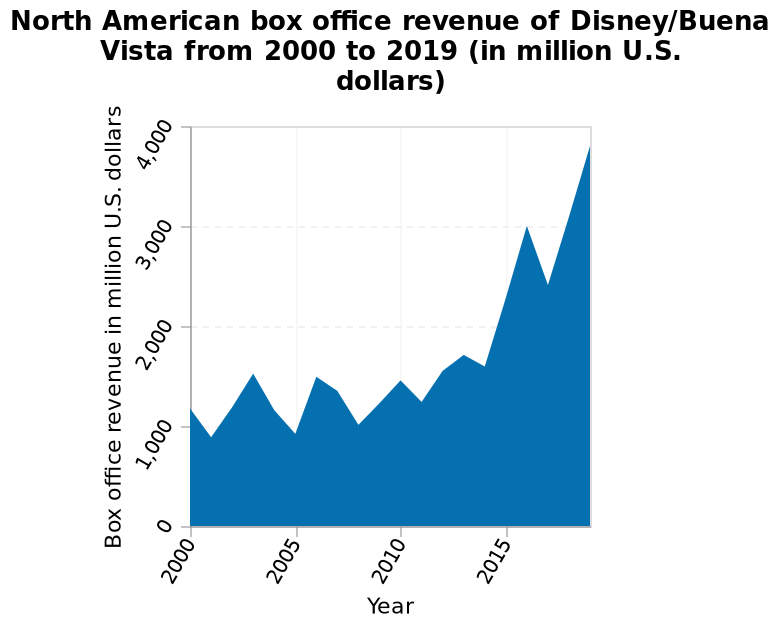<image>
please describe the details of the chart Here a is a area diagram titled North American box office revenue of Disney/Buena Vista from 2000 to 2019 (in million U.S. dollars). The y-axis shows Box office revenue in million U.S. dollars with linear scale from 0 to 4,000 while the x-axis measures Year using linear scale of range 2000 to 2015. please summary the statistics and relations of the chart Despite some drops in revenue, the chart shows a steady increase. 2019 took the highest revenue with almost 4,000 million US dollars. Around 2001 seen the lowest revenue with just under 1,000. Between the years around 2014 and 2017, Disney had the biggest increase going from 1500 to 3000, appearing to almost double. Was there any drop in Disney's revenue over the years? Yes, there were some drops in Disney's revenue, but overall, it shows a steady increase. 